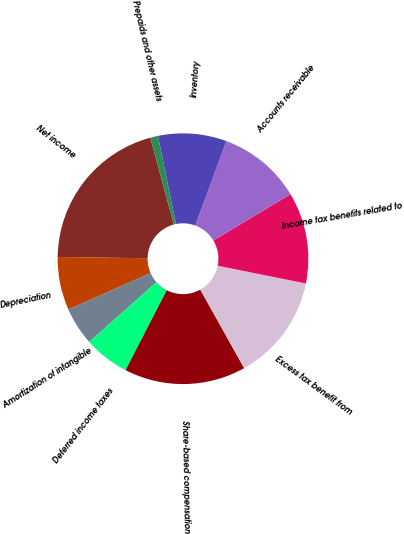Convert chart. <chart><loc_0><loc_0><loc_500><loc_500><pie_chart><fcel>Net income<fcel>Depreciation<fcel>Amortization of intangible<fcel>Deferred income taxes<fcel>Share-based compensation<fcel>Excess tax benefit from<fcel>Income tax benefits related to<fcel>Accounts receivable<fcel>Inventory<fcel>Prepaids and other assets<nl><fcel>20.58%<fcel>6.86%<fcel>4.9%<fcel>5.88%<fcel>15.68%<fcel>13.72%<fcel>11.76%<fcel>10.78%<fcel>8.82%<fcel>0.99%<nl></chart> 